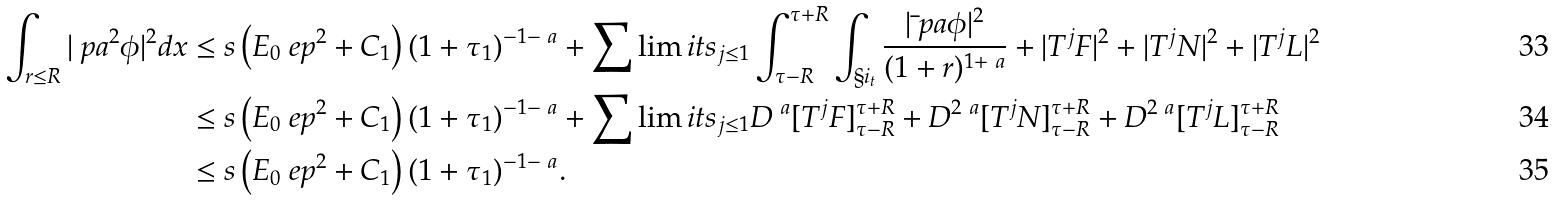<formula> <loc_0><loc_0><loc_500><loc_500>\int _ { r \leq R } | \ p a ^ { 2 } \phi | ^ { 2 } d x & \leq s \left ( E _ { 0 } \ e p ^ { 2 } + C _ { 1 } \right ) ( 1 + \tau _ { 1 } ) ^ { - 1 - \ a } + \sum \lim i t s _ { j \leq 1 } \int _ { \tau - R } ^ { \tau + R } \int _ { \S i _ { t } } \frac { | \bar { \ } p a \phi | ^ { 2 } } { ( 1 + r ) ^ { 1 + \ a } } + | T ^ { j } F | ^ { 2 } + | T ^ { j } N | ^ { 2 } + | T ^ { j } L | ^ { 2 } \\ & \leq s \left ( E _ { 0 } \ e p ^ { 2 } + C _ { 1 } \right ) ( 1 + \tau _ { 1 } ) ^ { - 1 - \ a } + \sum \lim i t s _ { j \leq 1 } D ^ { \ a } [ T ^ { j } F ] _ { \tau - R } ^ { \tau + R } + D ^ { 2 \ a } [ T ^ { j } N ] _ { \tau - R } ^ { \tau + R } + D ^ { 2 \ a } [ T ^ { j } L ] _ { \tau - R } ^ { \tau + R } \\ & \leq s \left ( E _ { 0 } \ e p ^ { 2 } + C _ { 1 } \right ) ( 1 + \tau _ { 1 } ) ^ { - 1 - \ a } .</formula> 